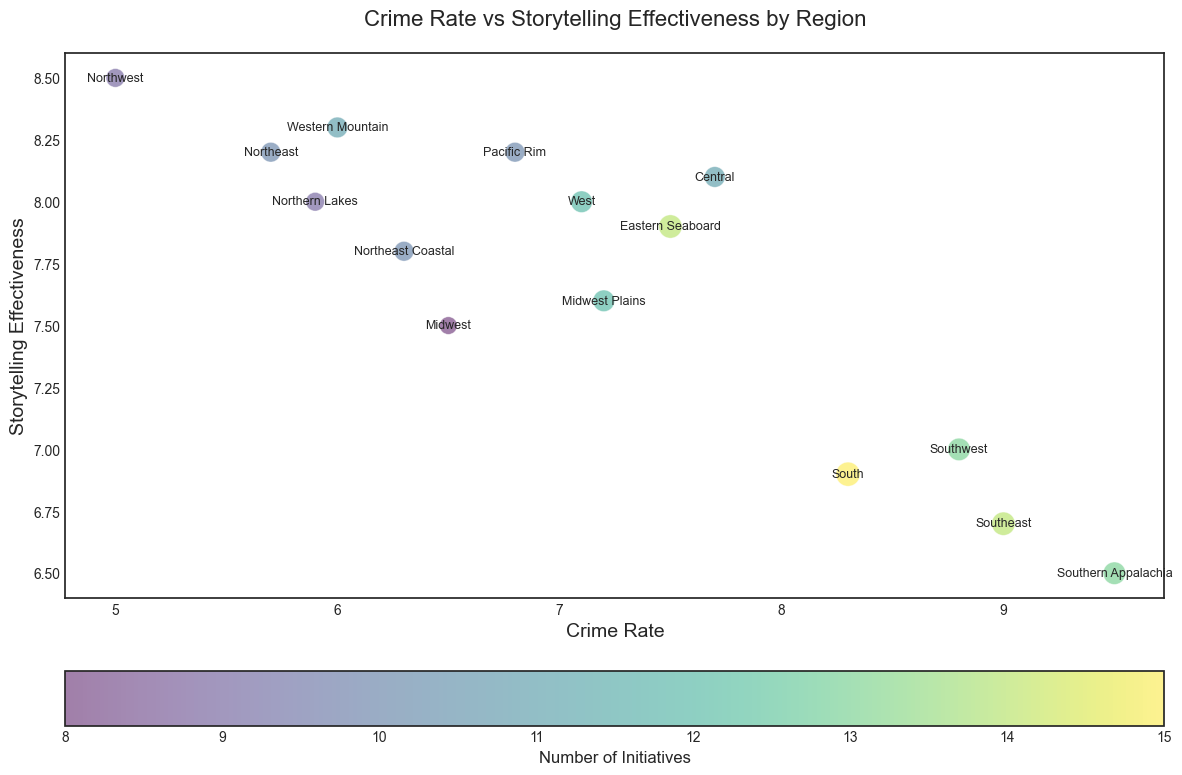Which region has the highest crime rate? By looking at the horizontal axis, locate the point that is furthest to the right. This represents the region with the highest crime rate. According to the data, this point corresponds to Southern Appalachia.
Answer: Southern Appalachia Which region has the highest storytelling effectiveness? Check the vertical axis and find the point that is highest up. This indicates the region with the highest storytelling effectiveness. The point belongs to Northwest.
Answer: Northwest What is the average crime rate of Northeast, South, and Western Mountain? Add the crime rates of these regions: Northeast (5.7) + South (8.3) + Western Mountain (6.0), which equals 20. Then, divide by the number of regions (3). 20/3 = 6.67.
Answer: 6.67 How many initiatives does the region with the lowest crime rate have? Locate the point with the lowest value on the horizontal axis (Crime Rate). This is Northwest with a crime rate of 5.0. According to the data, Northwest has 9 initiatives.
Answer: 9 Which region with a storytelling effectiveness above 8.0 has the smallest bubble (least initiatives)? Identify points with storytelling effectiveness higher than 8.0 on the vertical axis (8.2 for Northwest, Northeast, and Pacific Rim, 8.3 for Western Mountain). Of these, choose the one with the smallest bubble size. The smallest bubble (least initiatives = 9) is with Northwest.
Answer: Northwest What is the difference in crime rates between the regions with the highest and lowest storytelling effectiveness? The region with the highest storytelling effectiveness is Northwest with 8.5, and the lowest is Southern Appalachia with 6.5. The difference in their crime rates is 5.0 (Northwest) - 9.5 (Southern Appalachia) = -4.5.
Answer: -4.5 Which region has more initiatives, South or Eastern Seaboard? Refer to the bubble size or color intensity. South has 15 initiatives, and Eastern Seaboard has 14.
Answer: South What's the combined number of initiatives for Central and Northeast Coastal regions? Sum the number of initiatives for these regions. Central has 11 and Northeast Coastal has 10. 11 + 10 = 21.
Answer: 21 